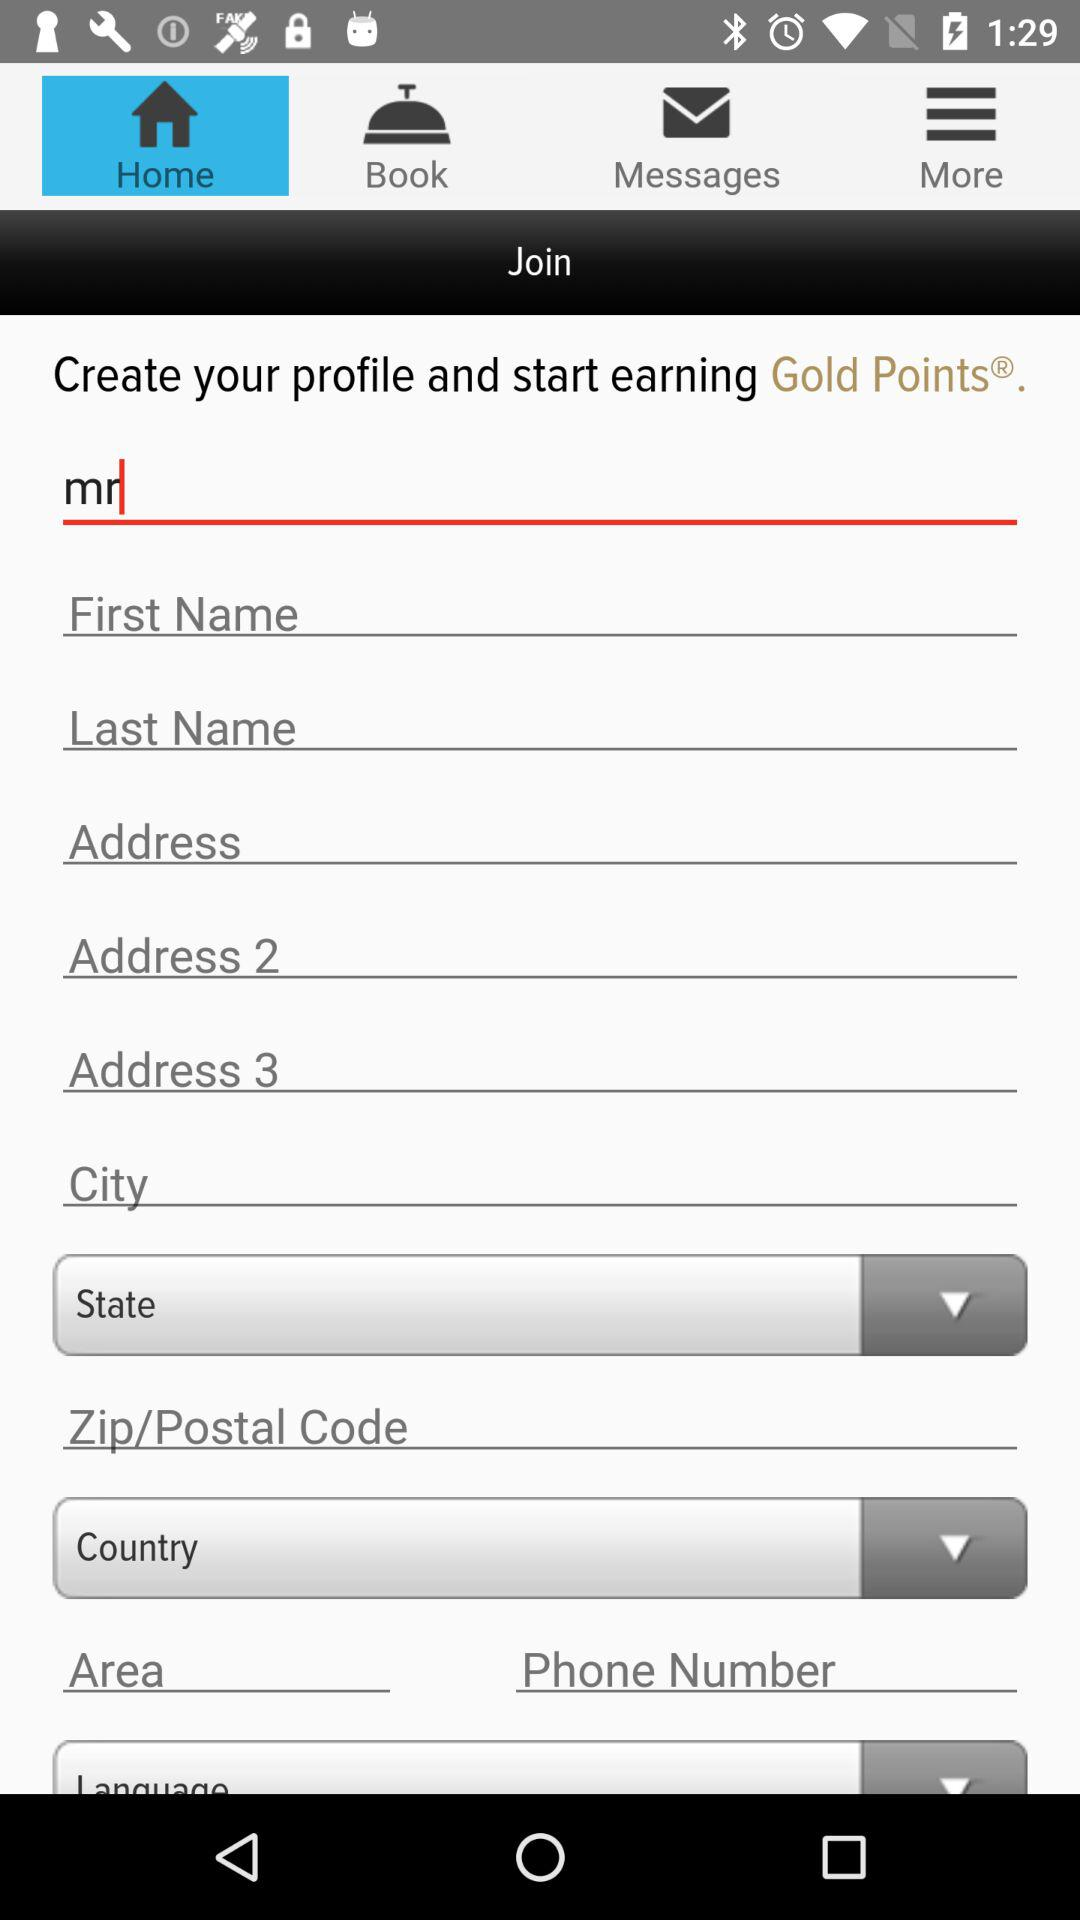Which tab is currently selected? The currently selected tab is "Home". 